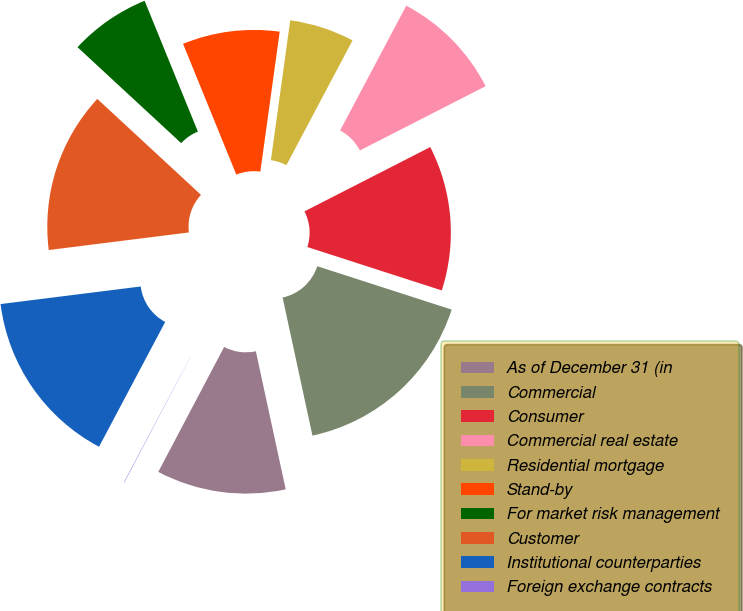Convert chart to OTSL. <chart><loc_0><loc_0><loc_500><loc_500><pie_chart><fcel>As of December 31 (in<fcel>Commercial<fcel>Consumer<fcel>Commercial real estate<fcel>Residential mortgage<fcel>Stand-by<fcel>For market risk management<fcel>Customer<fcel>Institutional counterparties<fcel>Foreign exchange contracts<nl><fcel>11.11%<fcel>16.64%<fcel>12.49%<fcel>9.72%<fcel>5.57%<fcel>8.34%<fcel>6.96%<fcel>13.87%<fcel>15.25%<fcel>0.04%<nl></chart> 